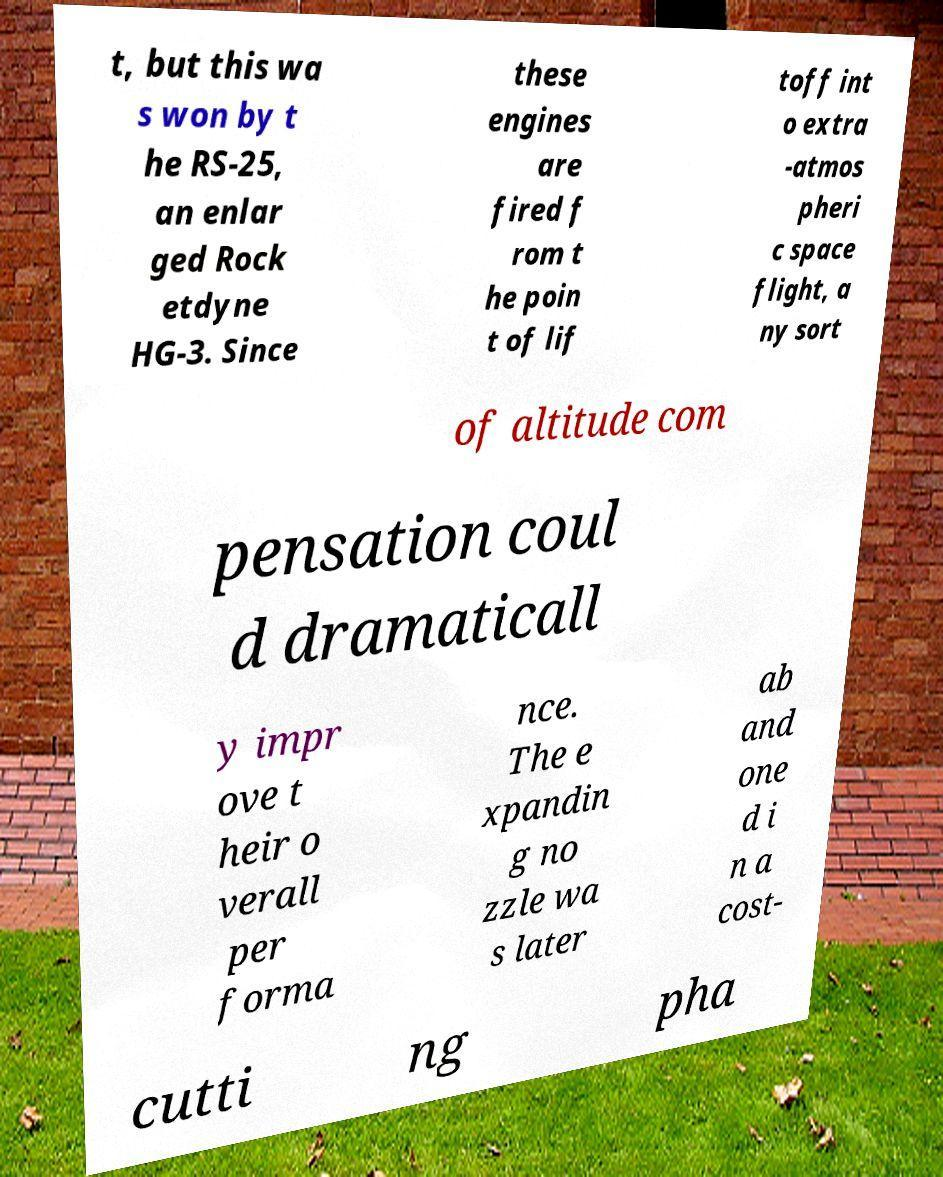Could you extract and type out the text from this image? t, but this wa s won by t he RS-25, an enlar ged Rock etdyne HG-3. Since these engines are fired f rom t he poin t of lif toff int o extra -atmos pheri c space flight, a ny sort of altitude com pensation coul d dramaticall y impr ove t heir o verall per forma nce. The e xpandin g no zzle wa s later ab and one d i n a cost- cutti ng pha 